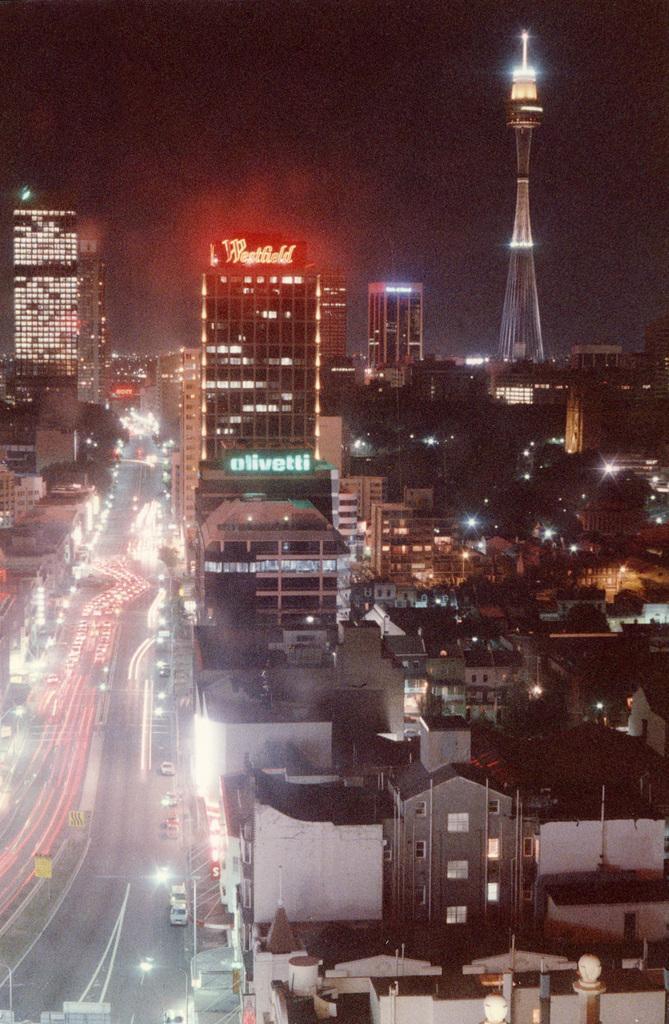Can you describe this image briefly? In this image there are few vehicles on the road. Right side there is a tower having lights. There are few buildings and trees. Top of image there is sky. 